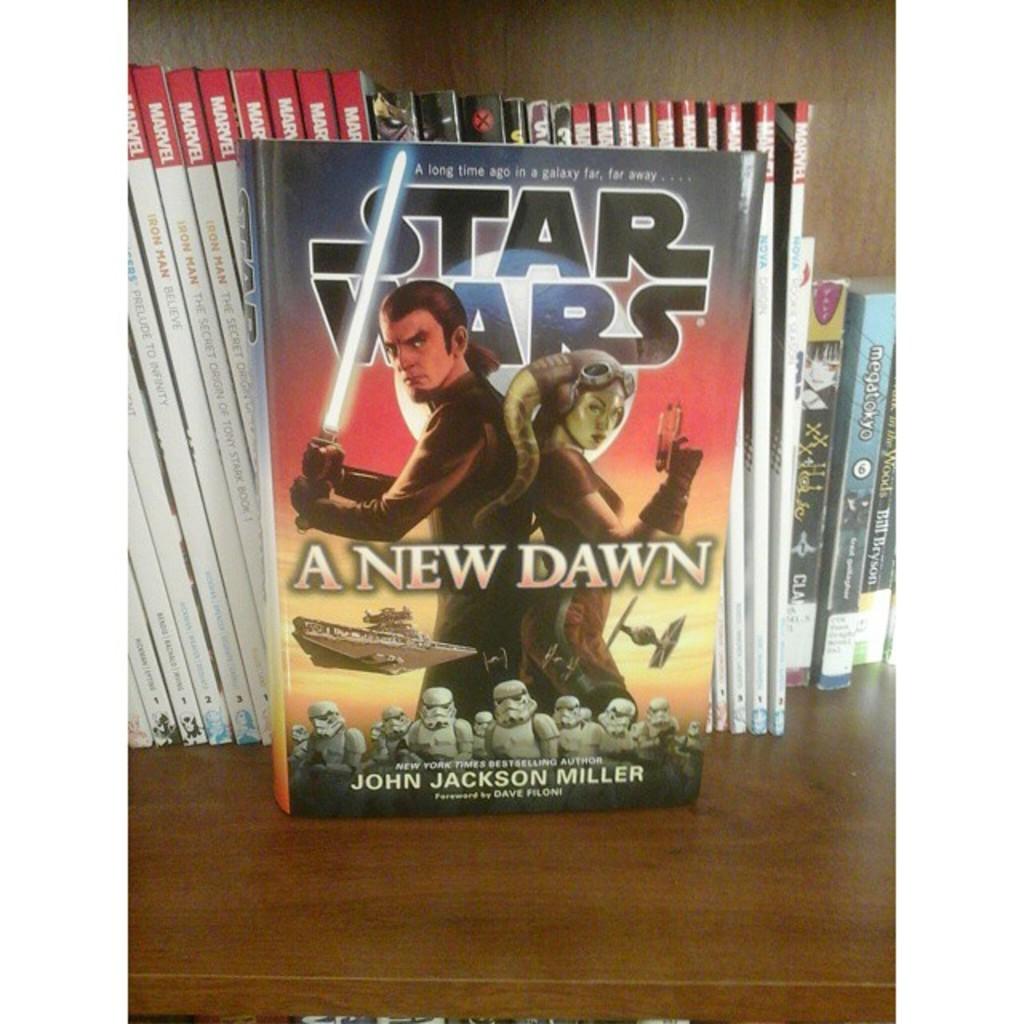Who is the author of this novel?
Make the answer very short. John jackson miller. What series is this book in?
Make the answer very short. Star wars. 